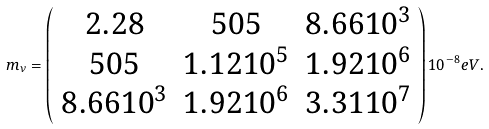Convert formula to latex. <formula><loc_0><loc_0><loc_500><loc_500>m _ { \nu } = \left ( \begin{array} { c c c } { 2 . 2 8 } & { 5 0 5 } & { { 8 . 6 6 1 0 ^ { 3 } } } \\ { 5 0 5 } & { { 1 . 1 2 1 0 ^ { 5 } } } & { { 1 . 9 2 1 0 ^ { 6 } } } \\ { { 8 . 6 6 1 0 ^ { 3 } } } & { { 1 . 9 2 1 0 ^ { 6 } } } & { { 3 . 3 1 1 0 ^ { 7 } } } \end{array} \right ) 1 0 ^ { - 8 } e V .</formula> 